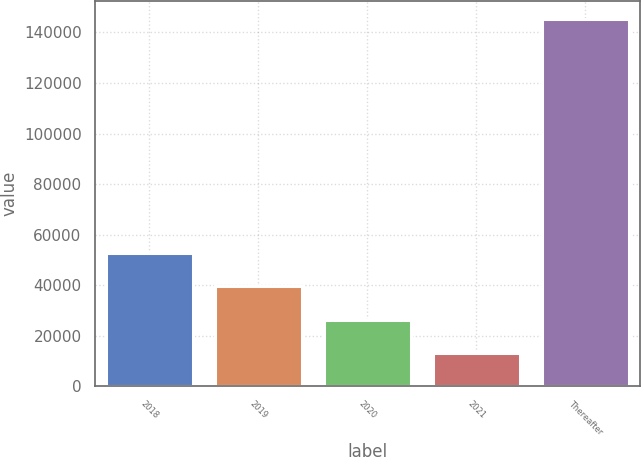<chart> <loc_0><loc_0><loc_500><loc_500><bar_chart><fcel>2018<fcel>2019<fcel>2020<fcel>2021<fcel>Thereafter<nl><fcel>52667.7<fcel>39446.8<fcel>26225.9<fcel>13005<fcel>145214<nl></chart> 